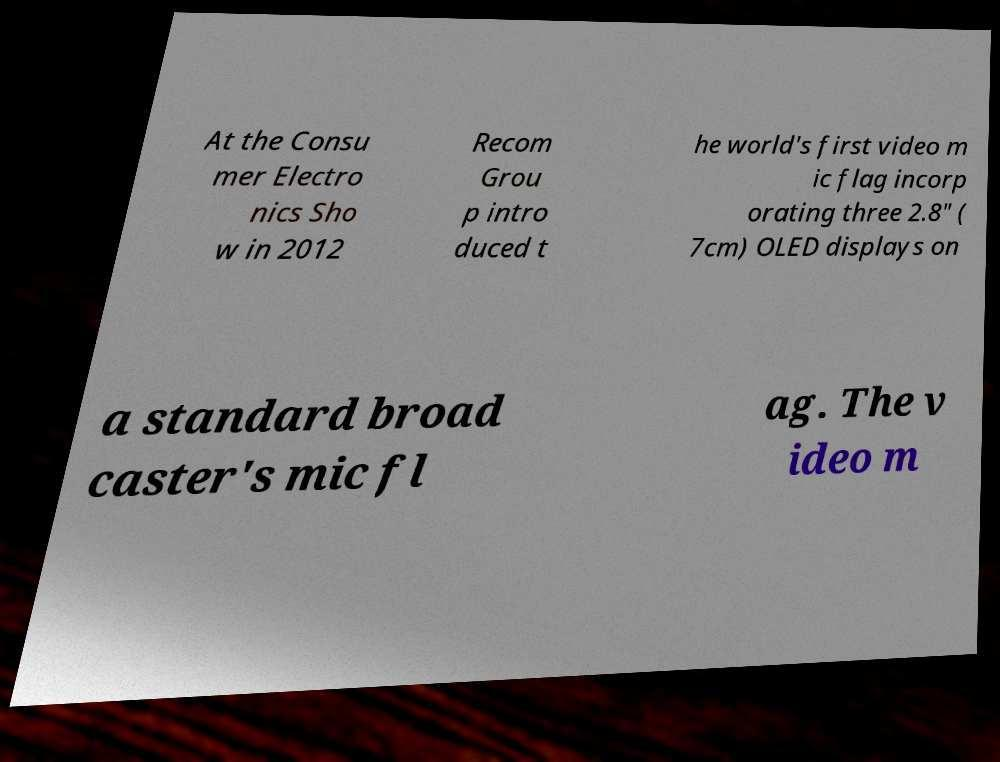Please identify and transcribe the text found in this image. At the Consu mer Electro nics Sho w in 2012 Recom Grou p intro duced t he world's first video m ic flag incorp orating three 2.8" ( 7cm) OLED displays on a standard broad caster's mic fl ag. The v ideo m 